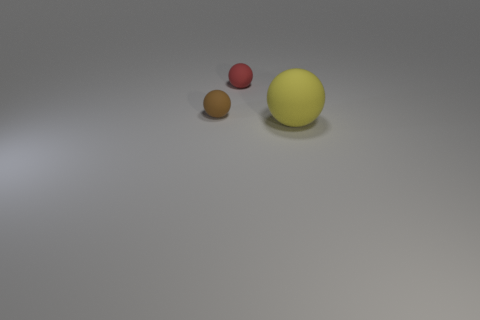How big is the ball that is to the right of the red rubber object that is behind the small matte ball to the left of the red matte ball?
Provide a succinct answer. Large. Is the number of big matte spheres that are behind the red matte object the same as the number of matte balls in front of the yellow sphere?
Provide a short and direct response. Yes. Is there anything else that is the same size as the yellow rubber thing?
Ensure brevity in your answer.  No. There is a red object that is the same shape as the brown rubber object; what is its material?
Your answer should be compact. Rubber. Are there any yellow matte balls that are right of the small object that is in front of the small rubber thing behind the small brown ball?
Your response must be concise. Yes. Are there more matte objects in front of the brown rubber thing than gray matte cubes?
Your answer should be very brief. Yes. What number of objects are either large purple matte balls or red matte balls?
Provide a short and direct response. 1. What color is the large sphere?
Provide a short and direct response. Yellow. How many other objects are there of the same color as the large rubber thing?
Your answer should be compact. 0. There is a tiny red ball; are there any small objects in front of it?
Your answer should be very brief. Yes. 